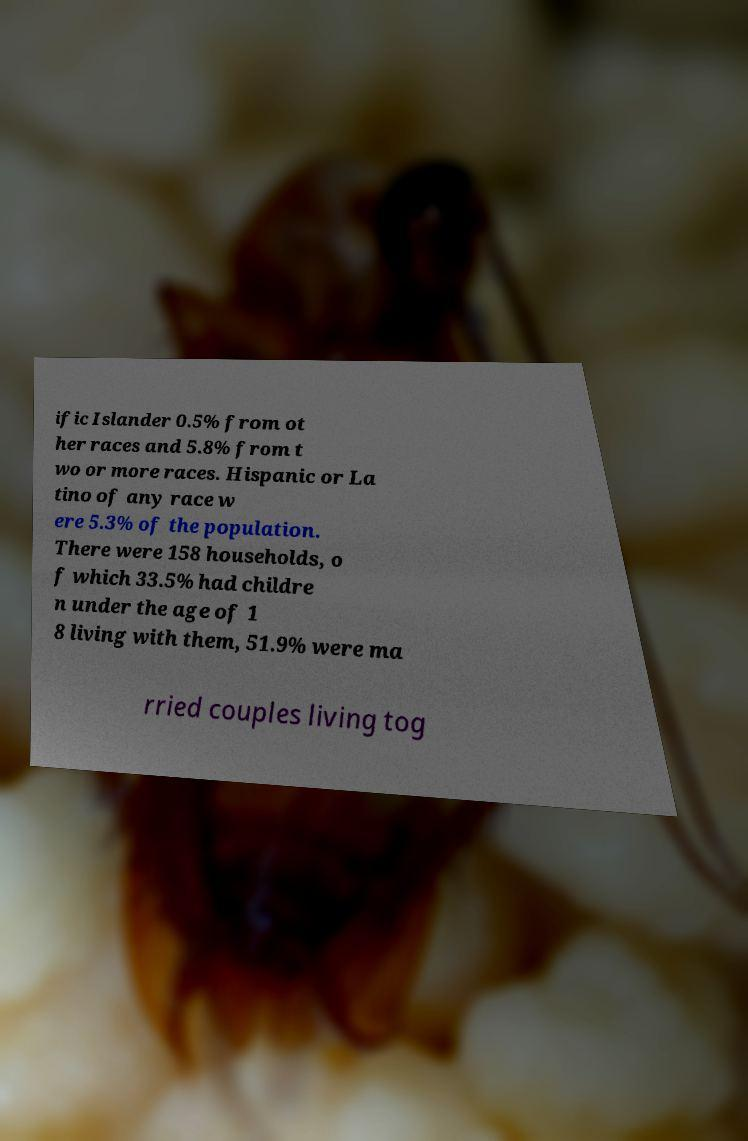Could you extract and type out the text from this image? ific Islander 0.5% from ot her races and 5.8% from t wo or more races. Hispanic or La tino of any race w ere 5.3% of the population. There were 158 households, o f which 33.5% had childre n under the age of 1 8 living with them, 51.9% were ma rried couples living tog 